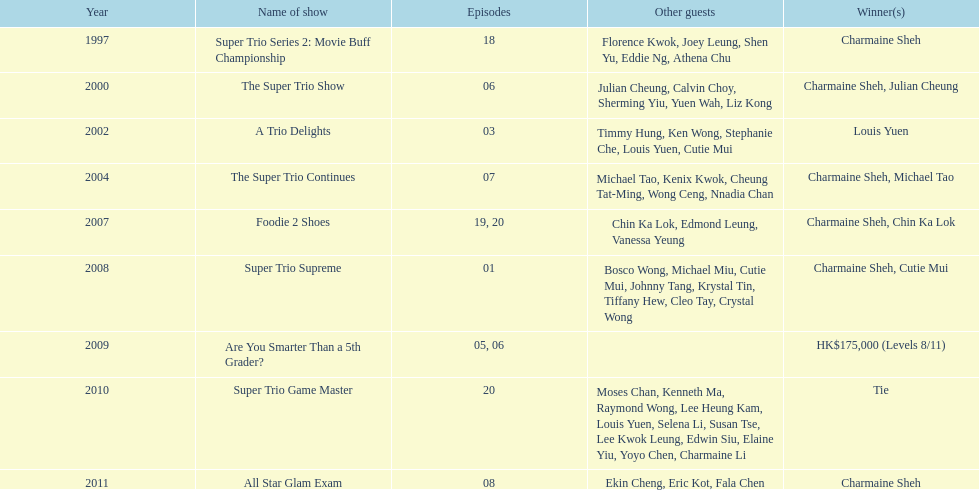In the variety show super trio 2: movie buff champions, how many episodes featured charmaine sheh? 18. 